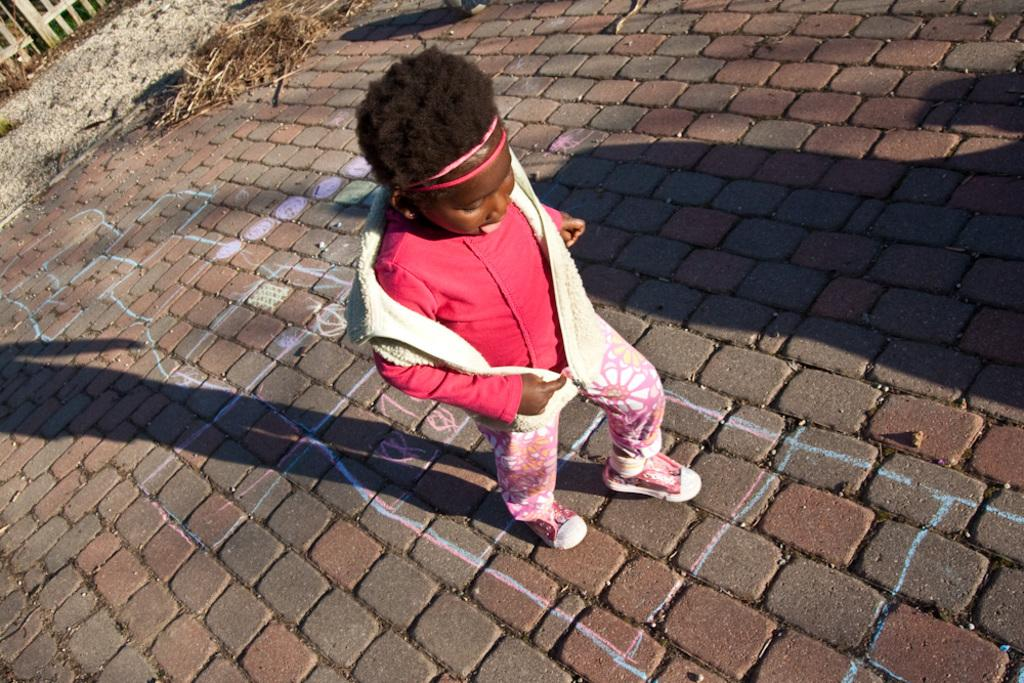What is the person in the image doing? The person is playing on the ground. What type of environment is visible in the background? There is grass and sand in the background, as well as a fence with bricks. Can you describe the fence in the background? The fence in the background is made of bricks. What flavor of ice cream is the person eating in the image? There is no ice cream present in the image, so it is not possible to determine the flavor. 